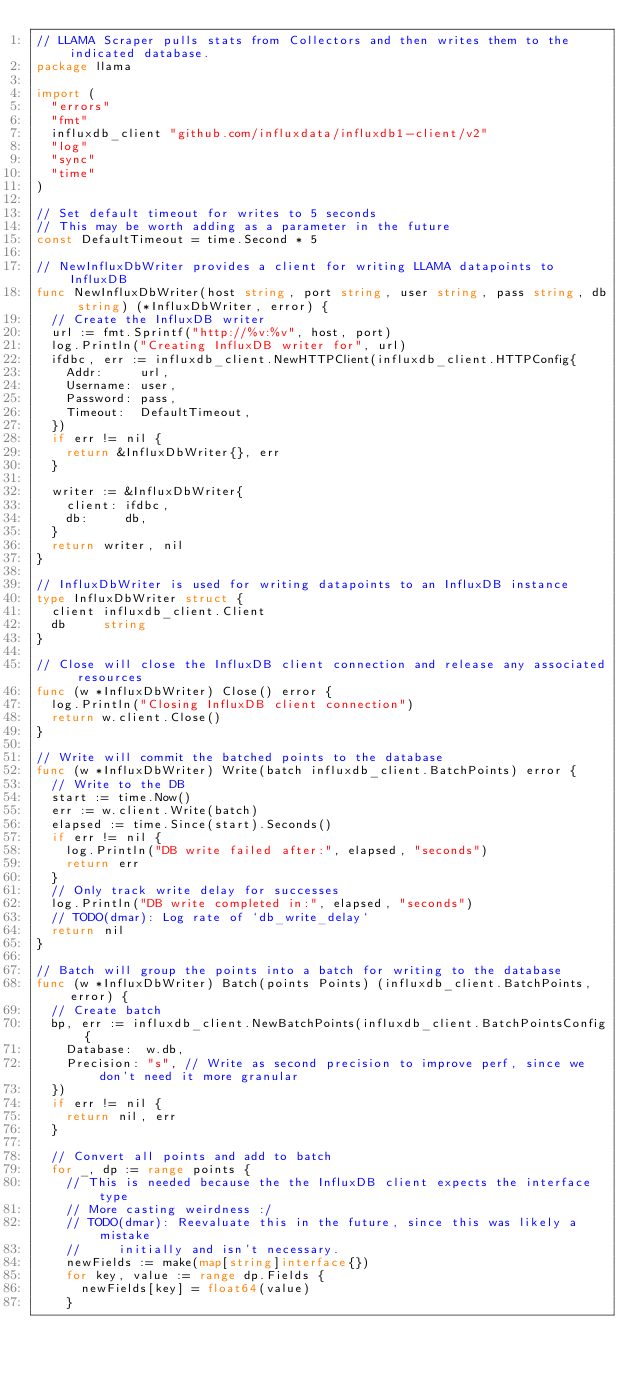Convert code to text. <code><loc_0><loc_0><loc_500><loc_500><_Go_>// LLAMA Scraper pulls stats from Collectors and then writes them to the indicated database.
package llama

import (
	"errors"
	"fmt"
	influxdb_client "github.com/influxdata/influxdb1-client/v2"
	"log"
	"sync"
	"time"
)

// Set default timeout for writes to 5 seconds
// This may be worth adding as a parameter in the future
const DefaultTimeout = time.Second * 5

// NewInfluxDbWriter provides a client for writing LLAMA datapoints to InfluxDB
func NewInfluxDbWriter(host string, port string, user string, pass string, db string) (*InfluxDbWriter, error) {
	// Create the InfluxDB writer
	url := fmt.Sprintf("http://%v:%v", host, port)
	log.Println("Creating InfluxDB writer for", url)
	ifdbc, err := influxdb_client.NewHTTPClient(influxdb_client.HTTPConfig{
		Addr:     url,
		Username: user,
		Password: pass,
		Timeout:  DefaultTimeout,
	})
	if err != nil {
		return &InfluxDbWriter{}, err
	}

	writer := &InfluxDbWriter{
		client: ifdbc,
		db:     db,
	}
	return writer, nil
}

// InfluxDbWriter is used for writing datapoints to an InfluxDB instance
type InfluxDbWriter struct {
	client influxdb_client.Client
	db     string
}

// Close will close the InfluxDB client connection and release any associated resources
func (w *InfluxDbWriter) Close() error {
	log.Println("Closing InfluxDB client connection")
	return w.client.Close()
}

// Write will commit the batched points to the database
func (w *InfluxDbWriter) Write(batch influxdb_client.BatchPoints) error {
	// Write to the DB
	start := time.Now()
	err := w.client.Write(batch)
	elapsed := time.Since(start).Seconds()
	if err != nil {
		log.Println("DB write failed after:", elapsed, "seconds")
		return err
	}
	// Only track write delay for successes
	log.Println("DB write completed in:", elapsed, "seconds")
	// TODO(dmar): Log rate of `db_write_delay`
	return nil
}

// Batch will group the points into a batch for writing to the database
func (w *InfluxDbWriter) Batch(points Points) (influxdb_client.BatchPoints, error) {
	// Create batch
	bp, err := influxdb_client.NewBatchPoints(influxdb_client.BatchPointsConfig{
		Database:  w.db,
		Precision: "s", // Write as second precision to improve perf, since we don't need it more granular
	})
	if err != nil {
		return nil, err
	}

	// Convert all points and add to batch
	for _, dp := range points {
		// This is needed because the the InfluxDB client expects the interface type
		// More casting weirdness :/
		// TODO(dmar): Reevaluate this in the future, since this was likely a mistake
		//     initially and isn't necessary.
		newFields := make(map[string]interface{})
		for key, value := range dp.Fields {
			newFields[key] = float64(value)
		}</code> 